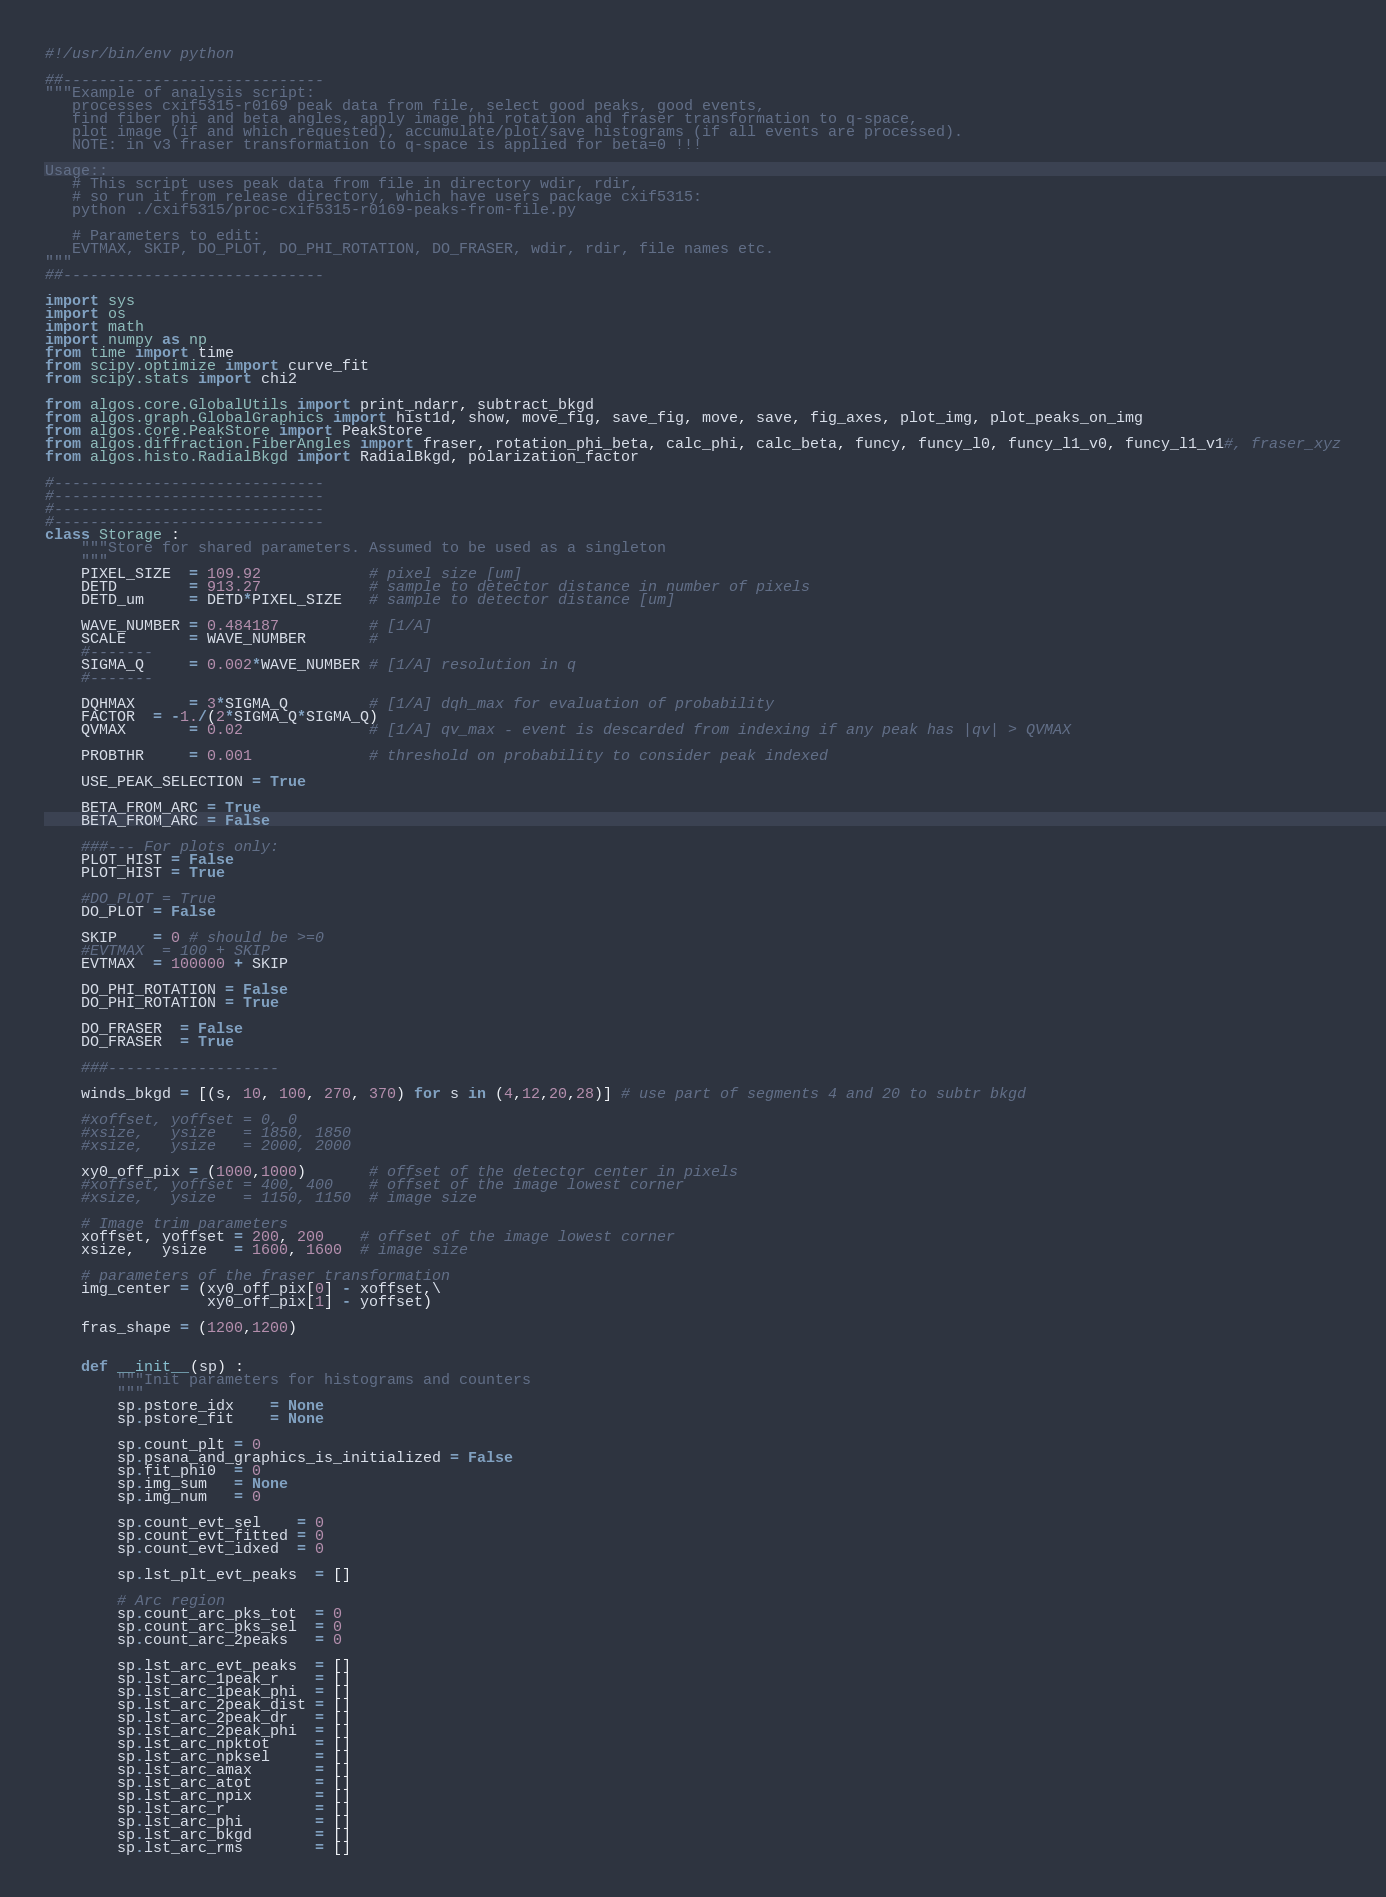Convert code to text. <code><loc_0><loc_0><loc_500><loc_500><_Python_>#!/usr/bin/env python

##-----------------------------
"""Example of analysis script:
   processes cxif5315-r0169 peak data from file, select good peaks, good events,
   find fiber phi and beta angles, apply image phi rotation and fraser transformation to q-space,
   plot image (if and which requested), accumulate/plot/save histograms (if all events are processed).
   NOTE: in v3 fraser transformation to q-space is applied for beta=0 !!!

Usage::
   # This script uses peak data from file in directory wdir, rdir,
   # so run it from release directory, which have users package cxif5315:
   python ./cxif5315/proc-cxif5315-r0169-peaks-from-file.py
    
   # Parameters to edit:
   EVTMAX, SKIP, DO_PLOT, DO_PHI_ROTATION, DO_FRASER, wdir, rdir, file names etc.
"""
##-----------------------------

import sys
import os
import math
import numpy as np
from time import time
from scipy.optimize import curve_fit
from scipy.stats import chi2

from algos.core.GlobalUtils import print_ndarr, subtract_bkgd
from algos.graph.GlobalGraphics import hist1d, show, move_fig, save_fig, move, save, fig_axes, plot_img, plot_peaks_on_img
from algos.core.PeakStore import PeakStore
from algos.diffraction.FiberAngles import fraser, rotation_phi_beta, calc_phi, calc_beta, funcy, funcy_l0, funcy_l1_v0, funcy_l1_v1#, fraser_xyz
from algos.histo.RadialBkgd import RadialBkgd, polarization_factor

#------------------------------
#------------------------------
#------------------------------
#------------------------------
class Storage :
    """Store for shared parameters. Assumed to be used as a singleton
    """
    PIXEL_SIZE  = 109.92            # pixel size [um]
    DETD        = 913.27            # sample to detector distance in number of pixels
    DETD_um     = DETD*PIXEL_SIZE   # sample to detector distance [um]

    WAVE_NUMBER = 0.484187          # [1/A]
    SCALE       = WAVE_NUMBER       # 
    #-------
    SIGMA_Q     = 0.002*WAVE_NUMBER # [1/A] resolution in q
    #-------

    DQHMAX      = 3*SIGMA_Q         # [1/A] dqh_max for evaluation of probability
    FACTOR  = -1./(2*SIGMA_Q*SIGMA_Q)
    QVMAX       = 0.02              # [1/A] qv_max - event is descarded from indexing if any peak has |qv| > QVMAX

    PROBTHR     = 0.001             # threshold on probability to consider peak indexed

    USE_PEAK_SELECTION = True

    BETA_FROM_ARC = True
    BETA_FROM_ARC = False
    
    ###--- For plots only:
    PLOT_HIST = False
    PLOT_HIST = True

    #DO_PLOT = True
    DO_PLOT = False

    SKIP    = 0 # should be >=0
    #EVTMAX  = 100 + SKIP
    EVTMAX  = 100000 + SKIP

    DO_PHI_ROTATION = False
    DO_PHI_ROTATION = True

    DO_FRASER  = False
    DO_FRASER  = True

    ###------------------- 

    winds_bkgd = [(s, 10, 100, 270, 370) for s in (4,12,20,28)] # use part of segments 4 and 20 to subtr bkgd

    #xoffset, yoffset = 0, 0
    #xsize,   ysize   = 1850, 1850
    #xsize,   ysize   = 2000, 2000

    xy0_off_pix = (1000,1000)       # offset of the detector center in pixels
    #xoffset, yoffset = 400, 400    # offset of the image lowest corner
    #xsize,   ysize   = 1150, 1150  # image size

    # Image trim parameters
    xoffset, yoffset = 200, 200    # offset of the image lowest corner
    xsize,   ysize   = 1600, 1600  # image size

    # parameters of the fraser transformation
    img_center = (xy0_off_pix[0] - xoffset,\
                  xy0_off_pix[1] - yoffset)

    fras_shape = (1200,1200)


    def __init__(sp) :
        """Init parameters for histograms and counters
        """
        sp.pstore_idx    = None
        sp.pstore_fit    = None

        sp.count_plt = 0
        sp.psana_and_graphics_is_initialized = False
        sp.fit_phi0  = 0
        sp.img_sum   = None
        sp.img_num   = 0

        sp.count_evt_sel    = 0
        sp.count_evt_fitted = 0
        sp.count_evt_idxed  = 0
    
        sp.lst_plt_evt_peaks  = []
    
        # Arc region
        sp.count_arc_pks_tot  = 0
        sp.count_arc_pks_sel  = 0
        sp.count_arc_2peaks   = 0
    
        sp.lst_arc_evt_peaks  = []
        sp.lst_arc_1peak_r    = []
        sp.lst_arc_1peak_phi  = []
        sp.lst_arc_2peak_dist = []
        sp.lst_arc_2peak_dr   = []
        sp.lst_arc_2peak_phi  = []
        sp.lst_arc_npktot     = []
        sp.lst_arc_npksel     = []
        sp.lst_arc_amax       = []
        sp.lst_arc_atot       = []
        sp.lst_arc_npix       = []
        sp.lst_arc_r          = []
        sp.lst_arc_phi        = []
        sp.lst_arc_bkgd       = []
        sp.lst_arc_rms        = []</code> 